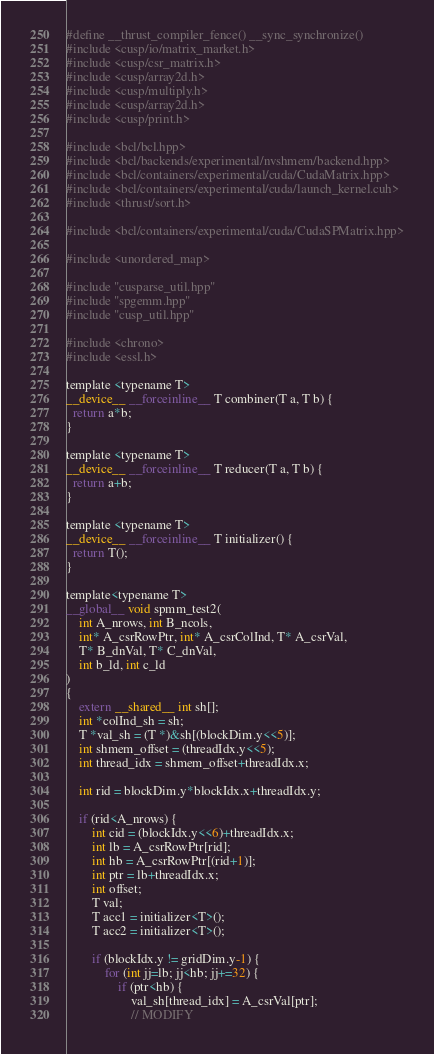Convert code to text. <code><loc_0><loc_0><loc_500><loc_500><_Cuda_>#define __thrust_compiler_fence() __sync_synchronize()
#include <cusp/io/matrix_market.h>
#include <cusp/csr_matrix.h>
#include <cusp/array2d.h>
#include <cusp/multiply.h>
#include <cusp/array2d.h>
#include <cusp/print.h>

#include <bcl/bcl.hpp>
#include <bcl/backends/experimental/nvshmem/backend.hpp>
#include <bcl/containers/experimental/cuda/CudaMatrix.hpp>
#include <bcl/containers/experimental/cuda/launch_kernel.cuh>
#include <thrust/sort.h>

#include <bcl/containers/experimental/cuda/CudaSPMatrix.hpp>

#include <unordered_map>

#include "cusparse_util.hpp"
#include "spgemm.hpp"
#include "cusp_util.hpp"

#include <chrono>
#include <essl.h>

template <typename T>
__device__ __forceinline__ T combiner(T a, T b) {
  return a*b;
}

template <typename T>
__device__ __forceinline__ T reducer(T a, T b) {
  return a+b;
}

template <typename T>
__device__ __forceinline__ T initializer() {
  return T();
}

template<typename T>
__global__ void spmm_test2(
    int A_nrows, int B_ncols,
    int* A_csrRowPtr, int* A_csrColInd, T* A_csrVal,
    T* B_dnVal, T* C_dnVal,
    int b_ld, int c_ld
)
{
    extern __shared__ int sh[];
    int *colInd_sh = sh;
    T *val_sh = (T *)&sh[(blockDim.y<<5)];
    int shmem_offset = (threadIdx.y<<5);
    int thread_idx = shmem_offset+threadIdx.x;

    int rid = blockDim.y*blockIdx.x+threadIdx.y;
    
    if (rid<A_nrows) {
        int cid = (blockIdx.y<<6)+threadIdx.x;
        int lb = A_csrRowPtr[rid];
        int hb = A_csrRowPtr[(rid+1)];
        int ptr = lb+threadIdx.x;
        int offset;
        T val;
        T acc1 = initializer<T>();
        T acc2 = initializer<T>();

        if (blockIdx.y != gridDim.y-1) {
            for (int jj=lb; jj<hb; jj+=32) {
                if (ptr<hb) {
                    val_sh[thread_idx] = A_csrVal[ptr];
                    // MODIFY</code> 